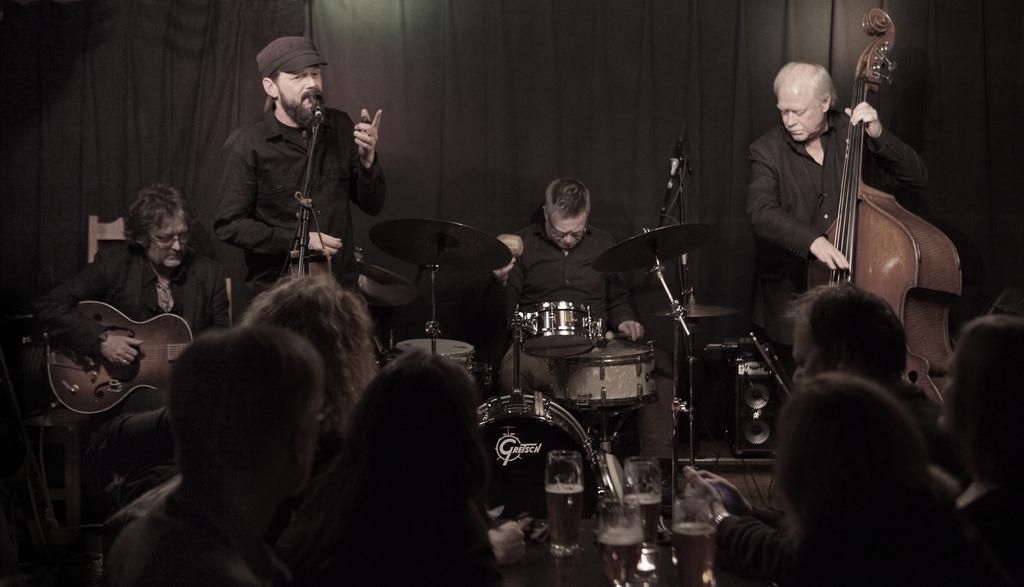In one or two sentences, can you explain what this image depicts? As we can see in the image, there are few group of people. The person on the left is holding guitar in his hand and this person is singing a song on mike and this person is playing drums and the person on the right side is holding guitar in his hand and these group of people are looking at them. 